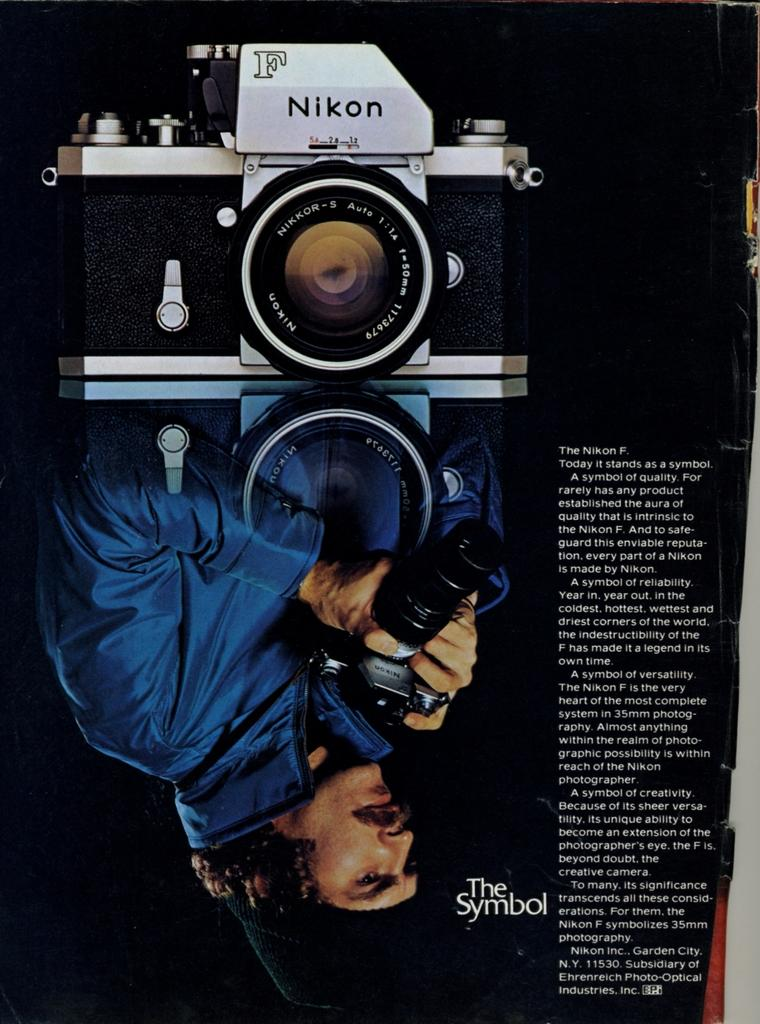What object can be seen in the image? There is a book in the image. Can you describe the book in the image? The book appears to be a hardcover book with a visible spine. What might someone be doing with the book in the image? It is unclear what the person is doing with the book, but they may be reading, holding, or placing it. How many snakes are wrapped around the book in the image? There are no snakes present in the image; it only features a book. What type of care does the book require in the image? The book does not require any specific care in the image, as it is a static object. 